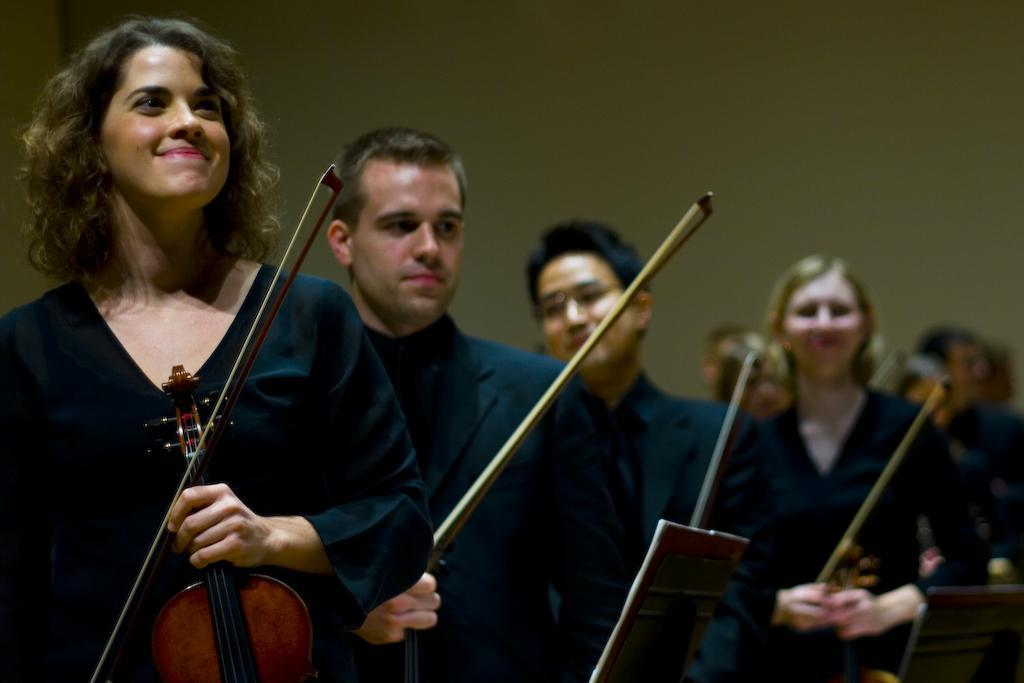How many people are in the image? There are persons in the image. What are the persons holding in their hands? The persons are holding guitars with their hands. What can be seen in the background of the image? There is a wall in the background of the image. What type of lettuce is being used for the operation in the image? There is no lettuce or operation present in the image; it features persons holding guitars. 